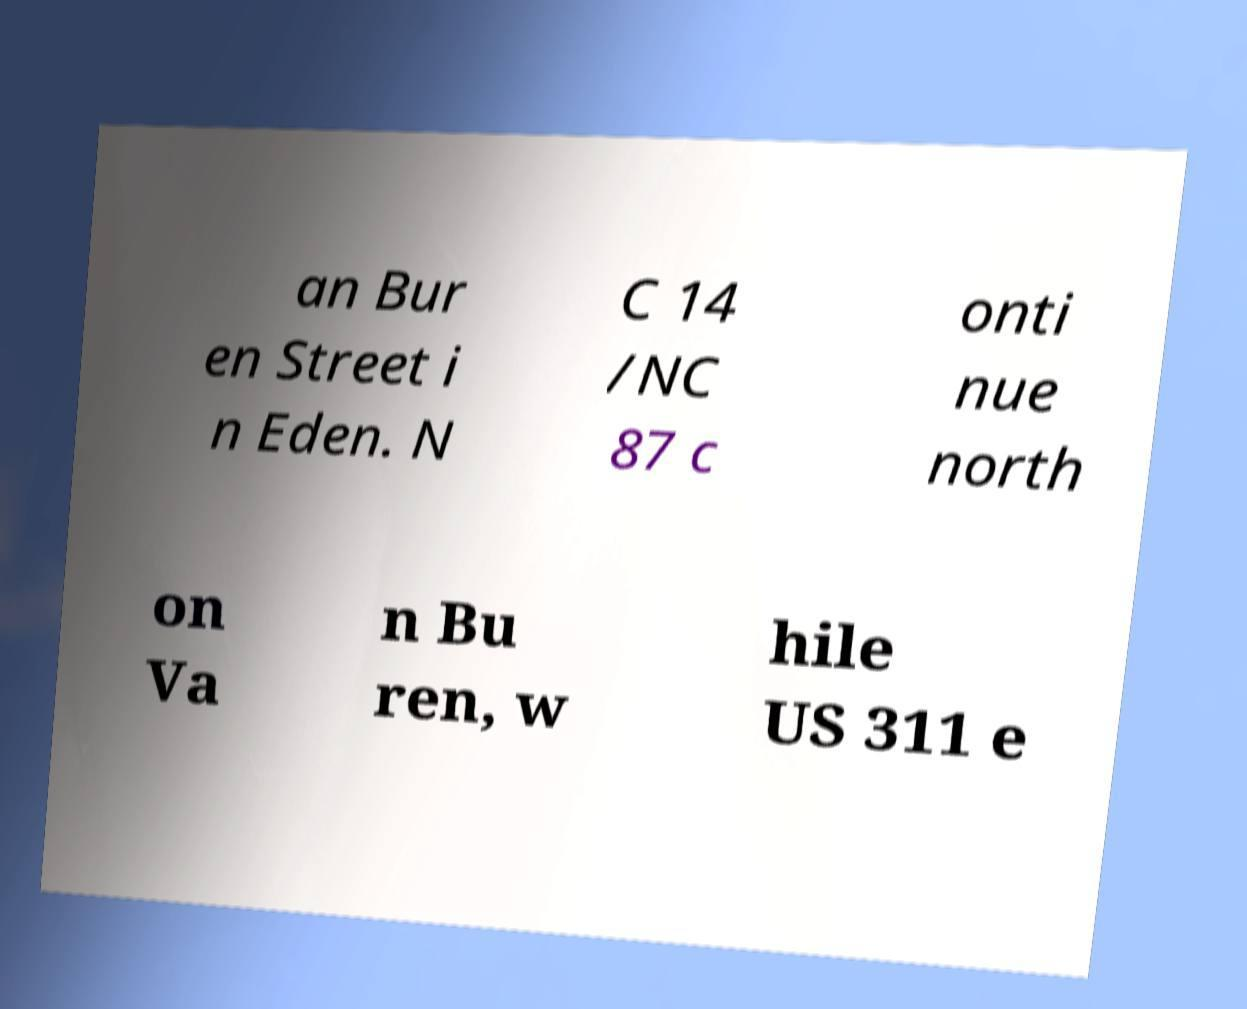Please identify and transcribe the text found in this image. an Bur en Street i n Eden. N C 14 /NC 87 c onti nue north on Va n Bu ren, w hile US 311 e 